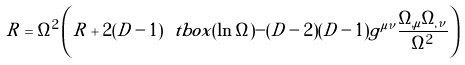Convert formula to latex. <formula><loc_0><loc_0><loc_500><loc_500>R = \Omega ^ { 2 } \left ( \tilde { R } + 2 ( D - 1 ) \ t b o x ( \ln \Omega ) - ( D - 2 ) ( D - 1 ) \tilde { g } ^ { \mu \nu } \frac { \Omega _ { , \mu } \Omega _ { , \nu } } { \Omega ^ { 2 } } \right )</formula> 